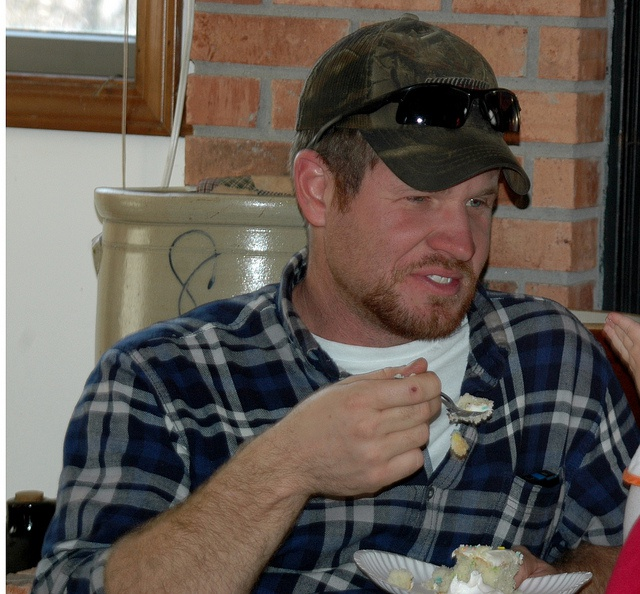Describe the objects in this image and their specific colors. I can see people in white, black, gray, and purple tones, cake in white, darkgray, gray, and lightgray tones, cake in white, darkgray, gray, and black tones, spoon in white, gray, black, and darkgray tones, and fork in white, gray, darkgray, and black tones in this image. 